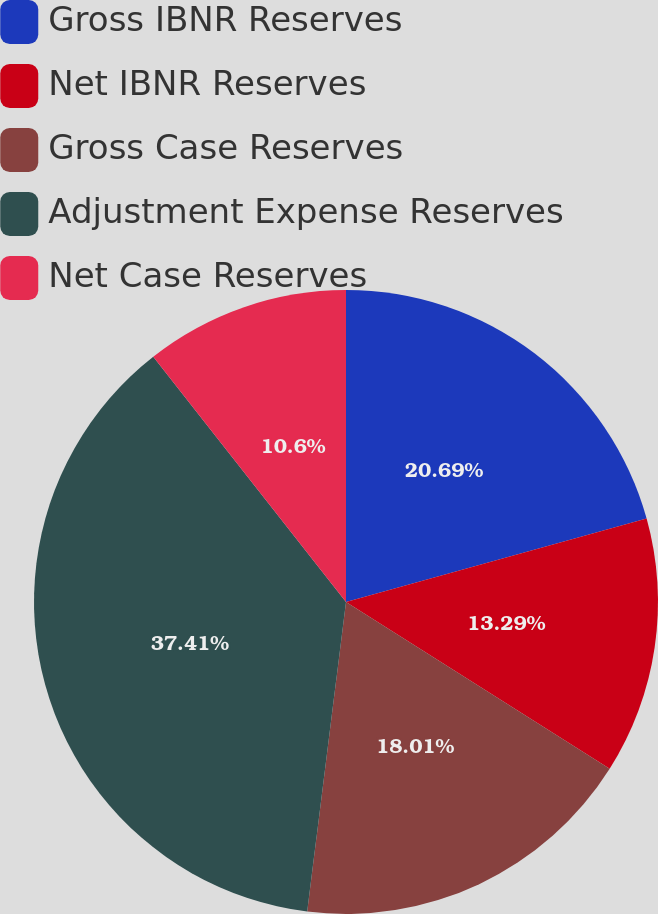<chart> <loc_0><loc_0><loc_500><loc_500><pie_chart><fcel>Gross IBNR Reserves<fcel>Net IBNR Reserves<fcel>Gross Case Reserves<fcel>Adjustment Expense Reserves<fcel>Net Case Reserves<nl><fcel>20.69%<fcel>13.29%<fcel>18.01%<fcel>37.42%<fcel>10.6%<nl></chart> 